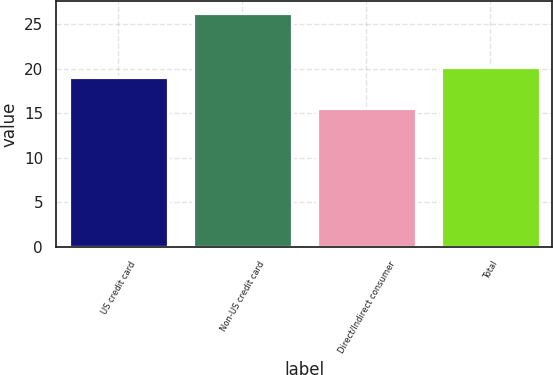Convert chart to OTSL. <chart><loc_0><loc_0><loc_500><loc_500><bar_chart><fcel>US credit card<fcel>Non-US credit card<fcel>Direct/Indirect consumer<fcel>Total<nl><fcel>19.04<fcel>26.32<fcel>15.63<fcel>20.2<nl></chart> 